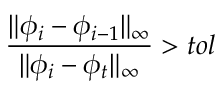Convert formula to latex. <formula><loc_0><loc_0><loc_500><loc_500>\frac { \| \phi _ { i } - \phi _ { i - 1 } \| _ { \infty } } { \| \phi _ { i } - \phi _ { t } \| _ { \infty } } > t o l</formula> 